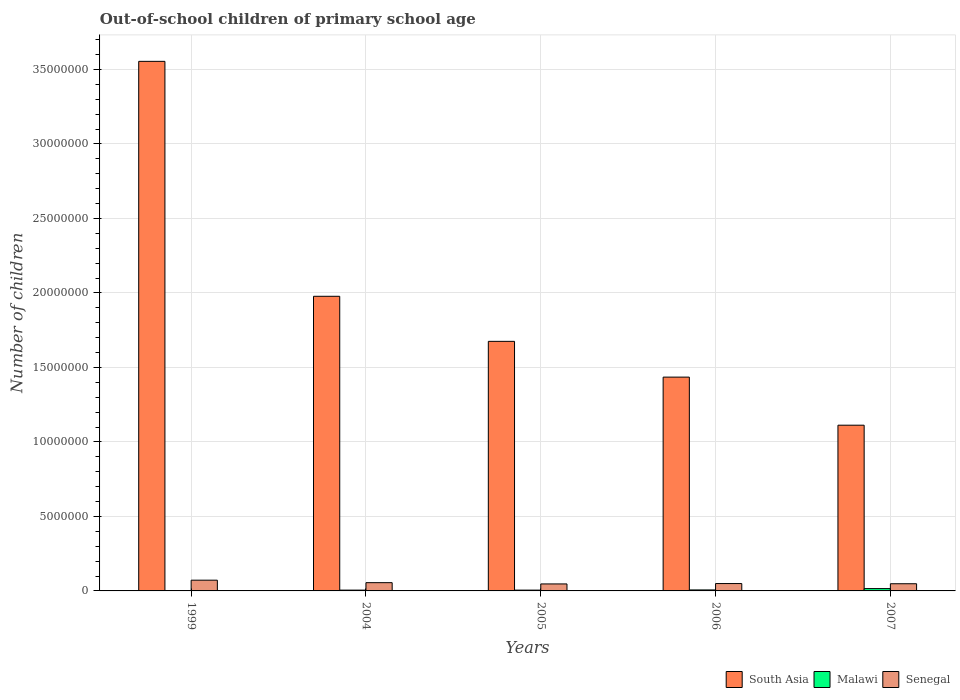How many different coloured bars are there?
Your answer should be compact. 3. Are the number of bars per tick equal to the number of legend labels?
Your answer should be very brief. Yes. How many bars are there on the 1st tick from the right?
Your answer should be compact. 3. What is the number of out-of-school children in South Asia in 2004?
Offer a terse response. 1.98e+07. Across all years, what is the maximum number of out-of-school children in South Asia?
Your response must be concise. 3.55e+07. Across all years, what is the minimum number of out-of-school children in Malawi?
Give a very brief answer. 1.75e+04. In which year was the number of out-of-school children in Malawi maximum?
Provide a short and direct response. 2007. What is the total number of out-of-school children in Malawi in the graph?
Your response must be concise. 3.49e+05. What is the difference between the number of out-of-school children in Senegal in 2005 and that in 2007?
Your response must be concise. -1.23e+04. What is the difference between the number of out-of-school children in South Asia in 2007 and the number of out-of-school children in Senegal in 2006?
Your answer should be compact. 1.06e+07. What is the average number of out-of-school children in Senegal per year?
Your answer should be compact. 5.44e+05. In the year 2006, what is the difference between the number of out-of-school children in South Asia and number of out-of-school children in Malawi?
Your response must be concise. 1.43e+07. In how many years, is the number of out-of-school children in South Asia greater than 27000000?
Make the answer very short. 1. What is the ratio of the number of out-of-school children in Senegal in 1999 to that in 2006?
Make the answer very short. 1.46. Is the number of out-of-school children in Senegal in 1999 less than that in 2005?
Offer a very short reply. No. Is the difference between the number of out-of-school children in South Asia in 1999 and 2007 greater than the difference between the number of out-of-school children in Malawi in 1999 and 2007?
Give a very brief answer. Yes. What is the difference between the highest and the second highest number of out-of-school children in Malawi?
Give a very brief answer. 9.06e+04. What is the difference between the highest and the lowest number of out-of-school children in Senegal?
Make the answer very short. 2.52e+05. In how many years, is the number of out-of-school children in South Asia greater than the average number of out-of-school children in South Asia taken over all years?
Your response must be concise. 2. How many bars are there?
Provide a succinct answer. 15. Are all the bars in the graph horizontal?
Provide a short and direct response. No. How many years are there in the graph?
Give a very brief answer. 5. Does the graph contain any zero values?
Your answer should be very brief. No. Does the graph contain grids?
Offer a very short reply. Yes. Where does the legend appear in the graph?
Your response must be concise. Bottom right. How are the legend labels stacked?
Your answer should be compact. Horizontal. What is the title of the graph?
Ensure brevity in your answer.  Out-of-school children of primary school age. What is the label or title of the Y-axis?
Your answer should be very brief. Number of children. What is the Number of children in South Asia in 1999?
Your answer should be compact. 3.55e+07. What is the Number of children of Malawi in 1999?
Ensure brevity in your answer.  1.75e+04. What is the Number of children of Senegal in 1999?
Keep it short and to the point. 7.21e+05. What is the Number of children in South Asia in 2004?
Give a very brief answer. 1.98e+07. What is the Number of children of Malawi in 2004?
Offer a very short reply. 5.41e+04. What is the Number of children in Senegal in 2004?
Your response must be concise. 5.54e+05. What is the Number of children in South Asia in 2005?
Keep it short and to the point. 1.67e+07. What is the Number of children in Malawi in 2005?
Provide a short and direct response. 5.37e+04. What is the Number of children in Senegal in 2005?
Your answer should be very brief. 4.69e+05. What is the Number of children of South Asia in 2006?
Provide a succinct answer. 1.44e+07. What is the Number of children in Malawi in 2006?
Your answer should be compact. 6.66e+04. What is the Number of children in Senegal in 2006?
Your answer should be very brief. 4.95e+05. What is the Number of children of South Asia in 2007?
Provide a succinct answer. 1.11e+07. What is the Number of children of Malawi in 2007?
Provide a short and direct response. 1.57e+05. What is the Number of children of Senegal in 2007?
Provide a short and direct response. 4.81e+05. Across all years, what is the maximum Number of children in South Asia?
Offer a very short reply. 3.55e+07. Across all years, what is the maximum Number of children in Malawi?
Your answer should be compact. 1.57e+05. Across all years, what is the maximum Number of children of Senegal?
Your answer should be compact. 7.21e+05. Across all years, what is the minimum Number of children of South Asia?
Provide a succinct answer. 1.11e+07. Across all years, what is the minimum Number of children of Malawi?
Provide a short and direct response. 1.75e+04. Across all years, what is the minimum Number of children in Senegal?
Your answer should be compact. 4.69e+05. What is the total Number of children of South Asia in the graph?
Provide a short and direct response. 9.75e+07. What is the total Number of children in Malawi in the graph?
Provide a succinct answer. 3.49e+05. What is the total Number of children of Senegal in the graph?
Provide a short and direct response. 2.72e+06. What is the difference between the Number of children in South Asia in 1999 and that in 2004?
Your response must be concise. 1.58e+07. What is the difference between the Number of children of Malawi in 1999 and that in 2004?
Ensure brevity in your answer.  -3.66e+04. What is the difference between the Number of children of Senegal in 1999 and that in 2004?
Make the answer very short. 1.66e+05. What is the difference between the Number of children of South Asia in 1999 and that in 2005?
Ensure brevity in your answer.  1.88e+07. What is the difference between the Number of children in Malawi in 1999 and that in 2005?
Your answer should be very brief. -3.62e+04. What is the difference between the Number of children in Senegal in 1999 and that in 2005?
Give a very brief answer. 2.52e+05. What is the difference between the Number of children in South Asia in 1999 and that in 2006?
Your answer should be compact. 2.12e+07. What is the difference between the Number of children in Malawi in 1999 and that in 2006?
Your answer should be compact. -4.91e+04. What is the difference between the Number of children of Senegal in 1999 and that in 2006?
Your answer should be compact. 2.26e+05. What is the difference between the Number of children in South Asia in 1999 and that in 2007?
Provide a succinct answer. 2.44e+07. What is the difference between the Number of children of Malawi in 1999 and that in 2007?
Ensure brevity in your answer.  -1.40e+05. What is the difference between the Number of children of Senegal in 1999 and that in 2007?
Provide a short and direct response. 2.39e+05. What is the difference between the Number of children of South Asia in 2004 and that in 2005?
Give a very brief answer. 3.03e+06. What is the difference between the Number of children in Malawi in 2004 and that in 2005?
Your answer should be very brief. 376. What is the difference between the Number of children in Senegal in 2004 and that in 2005?
Your response must be concise. 8.52e+04. What is the difference between the Number of children in South Asia in 2004 and that in 2006?
Your answer should be very brief. 5.42e+06. What is the difference between the Number of children of Malawi in 2004 and that in 2006?
Give a very brief answer. -1.25e+04. What is the difference between the Number of children of Senegal in 2004 and that in 2006?
Keep it short and to the point. 5.97e+04. What is the difference between the Number of children in South Asia in 2004 and that in 2007?
Make the answer very short. 8.65e+06. What is the difference between the Number of children of Malawi in 2004 and that in 2007?
Ensure brevity in your answer.  -1.03e+05. What is the difference between the Number of children of Senegal in 2004 and that in 2007?
Give a very brief answer. 7.29e+04. What is the difference between the Number of children of South Asia in 2005 and that in 2006?
Ensure brevity in your answer.  2.40e+06. What is the difference between the Number of children in Malawi in 2005 and that in 2006?
Give a very brief answer. -1.29e+04. What is the difference between the Number of children of Senegal in 2005 and that in 2006?
Provide a short and direct response. -2.55e+04. What is the difference between the Number of children of South Asia in 2005 and that in 2007?
Ensure brevity in your answer.  5.63e+06. What is the difference between the Number of children of Malawi in 2005 and that in 2007?
Your response must be concise. -1.03e+05. What is the difference between the Number of children in Senegal in 2005 and that in 2007?
Your answer should be compact. -1.23e+04. What is the difference between the Number of children of South Asia in 2006 and that in 2007?
Make the answer very short. 3.23e+06. What is the difference between the Number of children of Malawi in 2006 and that in 2007?
Your answer should be very brief. -9.06e+04. What is the difference between the Number of children in Senegal in 2006 and that in 2007?
Keep it short and to the point. 1.32e+04. What is the difference between the Number of children in South Asia in 1999 and the Number of children in Malawi in 2004?
Provide a short and direct response. 3.55e+07. What is the difference between the Number of children in South Asia in 1999 and the Number of children in Senegal in 2004?
Make the answer very short. 3.50e+07. What is the difference between the Number of children in Malawi in 1999 and the Number of children in Senegal in 2004?
Your response must be concise. -5.37e+05. What is the difference between the Number of children in South Asia in 1999 and the Number of children in Malawi in 2005?
Your answer should be compact. 3.55e+07. What is the difference between the Number of children of South Asia in 1999 and the Number of children of Senegal in 2005?
Keep it short and to the point. 3.51e+07. What is the difference between the Number of children in Malawi in 1999 and the Number of children in Senegal in 2005?
Your answer should be very brief. -4.52e+05. What is the difference between the Number of children in South Asia in 1999 and the Number of children in Malawi in 2006?
Keep it short and to the point. 3.55e+07. What is the difference between the Number of children in South Asia in 1999 and the Number of children in Senegal in 2006?
Offer a terse response. 3.50e+07. What is the difference between the Number of children of Malawi in 1999 and the Number of children of Senegal in 2006?
Your answer should be compact. -4.77e+05. What is the difference between the Number of children in South Asia in 1999 and the Number of children in Malawi in 2007?
Offer a very short reply. 3.54e+07. What is the difference between the Number of children in South Asia in 1999 and the Number of children in Senegal in 2007?
Ensure brevity in your answer.  3.51e+07. What is the difference between the Number of children of Malawi in 1999 and the Number of children of Senegal in 2007?
Offer a very short reply. -4.64e+05. What is the difference between the Number of children in South Asia in 2004 and the Number of children in Malawi in 2005?
Make the answer very short. 1.97e+07. What is the difference between the Number of children of South Asia in 2004 and the Number of children of Senegal in 2005?
Ensure brevity in your answer.  1.93e+07. What is the difference between the Number of children in Malawi in 2004 and the Number of children in Senegal in 2005?
Make the answer very short. -4.15e+05. What is the difference between the Number of children of South Asia in 2004 and the Number of children of Malawi in 2006?
Your answer should be compact. 1.97e+07. What is the difference between the Number of children in South Asia in 2004 and the Number of children in Senegal in 2006?
Provide a succinct answer. 1.93e+07. What is the difference between the Number of children of Malawi in 2004 and the Number of children of Senegal in 2006?
Your answer should be very brief. -4.41e+05. What is the difference between the Number of children in South Asia in 2004 and the Number of children in Malawi in 2007?
Offer a very short reply. 1.96e+07. What is the difference between the Number of children of South Asia in 2004 and the Number of children of Senegal in 2007?
Provide a short and direct response. 1.93e+07. What is the difference between the Number of children of Malawi in 2004 and the Number of children of Senegal in 2007?
Make the answer very short. -4.27e+05. What is the difference between the Number of children in South Asia in 2005 and the Number of children in Malawi in 2006?
Ensure brevity in your answer.  1.67e+07. What is the difference between the Number of children of South Asia in 2005 and the Number of children of Senegal in 2006?
Provide a succinct answer. 1.63e+07. What is the difference between the Number of children in Malawi in 2005 and the Number of children in Senegal in 2006?
Provide a succinct answer. -4.41e+05. What is the difference between the Number of children in South Asia in 2005 and the Number of children in Malawi in 2007?
Your response must be concise. 1.66e+07. What is the difference between the Number of children of South Asia in 2005 and the Number of children of Senegal in 2007?
Offer a terse response. 1.63e+07. What is the difference between the Number of children in Malawi in 2005 and the Number of children in Senegal in 2007?
Your response must be concise. -4.28e+05. What is the difference between the Number of children of South Asia in 2006 and the Number of children of Malawi in 2007?
Give a very brief answer. 1.42e+07. What is the difference between the Number of children in South Asia in 2006 and the Number of children in Senegal in 2007?
Make the answer very short. 1.39e+07. What is the difference between the Number of children of Malawi in 2006 and the Number of children of Senegal in 2007?
Offer a terse response. -4.15e+05. What is the average Number of children of South Asia per year?
Provide a succinct answer. 1.95e+07. What is the average Number of children of Malawi per year?
Keep it short and to the point. 6.98e+04. What is the average Number of children in Senegal per year?
Give a very brief answer. 5.44e+05. In the year 1999, what is the difference between the Number of children of South Asia and Number of children of Malawi?
Keep it short and to the point. 3.55e+07. In the year 1999, what is the difference between the Number of children of South Asia and Number of children of Senegal?
Your answer should be very brief. 3.48e+07. In the year 1999, what is the difference between the Number of children of Malawi and Number of children of Senegal?
Provide a short and direct response. -7.03e+05. In the year 2004, what is the difference between the Number of children of South Asia and Number of children of Malawi?
Your response must be concise. 1.97e+07. In the year 2004, what is the difference between the Number of children of South Asia and Number of children of Senegal?
Provide a short and direct response. 1.92e+07. In the year 2004, what is the difference between the Number of children in Malawi and Number of children in Senegal?
Keep it short and to the point. -5.00e+05. In the year 2005, what is the difference between the Number of children in South Asia and Number of children in Malawi?
Your answer should be compact. 1.67e+07. In the year 2005, what is the difference between the Number of children in South Asia and Number of children in Senegal?
Provide a short and direct response. 1.63e+07. In the year 2005, what is the difference between the Number of children in Malawi and Number of children in Senegal?
Your answer should be compact. -4.15e+05. In the year 2006, what is the difference between the Number of children in South Asia and Number of children in Malawi?
Offer a very short reply. 1.43e+07. In the year 2006, what is the difference between the Number of children in South Asia and Number of children in Senegal?
Provide a succinct answer. 1.39e+07. In the year 2006, what is the difference between the Number of children in Malawi and Number of children in Senegal?
Your answer should be compact. -4.28e+05. In the year 2007, what is the difference between the Number of children in South Asia and Number of children in Malawi?
Offer a very short reply. 1.10e+07. In the year 2007, what is the difference between the Number of children of South Asia and Number of children of Senegal?
Ensure brevity in your answer.  1.06e+07. In the year 2007, what is the difference between the Number of children in Malawi and Number of children in Senegal?
Give a very brief answer. -3.24e+05. What is the ratio of the Number of children in South Asia in 1999 to that in 2004?
Offer a terse response. 1.8. What is the ratio of the Number of children in Malawi in 1999 to that in 2004?
Your response must be concise. 0.32. What is the ratio of the Number of children of Senegal in 1999 to that in 2004?
Offer a very short reply. 1.3. What is the ratio of the Number of children of South Asia in 1999 to that in 2005?
Keep it short and to the point. 2.12. What is the ratio of the Number of children of Malawi in 1999 to that in 2005?
Give a very brief answer. 0.33. What is the ratio of the Number of children in Senegal in 1999 to that in 2005?
Provide a short and direct response. 1.54. What is the ratio of the Number of children of South Asia in 1999 to that in 2006?
Your response must be concise. 2.48. What is the ratio of the Number of children of Malawi in 1999 to that in 2006?
Provide a succinct answer. 0.26. What is the ratio of the Number of children in Senegal in 1999 to that in 2006?
Give a very brief answer. 1.46. What is the ratio of the Number of children of South Asia in 1999 to that in 2007?
Your answer should be compact. 3.2. What is the ratio of the Number of children in Malawi in 1999 to that in 2007?
Provide a short and direct response. 0.11. What is the ratio of the Number of children in Senegal in 1999 to that in 2007?
Offer a terse response. 1.5. What is the ratio of the Number of children of South Asia in 2004 to that in 2005?
Your answer should be compact. 1.18. What is the ratio of the Number of children of Malawi in 2004 to that in 2005?
Make the answer very short. 1.01. What is the ratio of the Number of children of Senegal in 2004 to that in 2005?
Provide a short and direct response. 1.18. What is the ratio of the Number of children in South Asia in 2004 to that in 2006?
Your answer should be very brief. 1.38. What is the ratio of the Number of children of Malawi in 2004 to that in 2006?
Keep it short and to the point. 0.81. What is the ratio of the Number of children of Senegal in 2004 to that in 2006?
Ensure brevity in your answer.  1.12. What is the ratio of the Number of children in South Asia in 2004 to that in 2007?
Ensure brevity in your answer.  1.78. What is the ratio of the Number of children of Malawi in 2004 to that in 2007?
Your answer should be very brief. 0.34. What is the ratio of the Number of children in Senegal in 2004 to that in 2007?
Your response must be concise. 1.15. What is the ratio of the Number of children of South Asia in 2005 to that in 2006?
Give a very brief answer. 1.17. What is the ratio of the Number of children of Malawi in 2005 to that in 2006?
Make the answer very short. 0.81. What is the ratio of the Number of children in Senegal in 2005 to that in 2006?
Make the answer very short. 0.95. What is the ratio of the Number of children of South Asia in 2005 to that in 2007?
Provide a succinct answer. 1.51. What is the ratio of the Number of children of Malawi in 2005 to that in 2007?
Ensure brevity in your answer.  0.34. What is the ratio of the Number of children of Senegal in 2005 to that in 2007?
Offer a terse response. 0.97. What is the ratio of the Number of children in South Asia in 2006 to that in 2007?
Keep it short and to the point. 1.29. What is the ratio of the Number of children of Malawi in 2006 to that in 2007?
Ensure brevity in your answer.  0.42. What is the ratio of the Number of children of Senegal in 2006 to that in 2007?
Offer a very short reply. 1.03. What is the difference between the highest and the second highest Number of children in South Asia?
Provide a succinct answer. 1.58e+07. What is the difference between the highest and the second highest Number of children in Malawi?
Ensure brevity in your answer.  9.06e+04. What is the difference between the highest and the second highest Number of children of Senegal?
Keep it short and to the point. 1.66e+05. What is the difference between the highest and the lowest Number of children in South Asia?
Your answer should be very brief. 2.44e+07. What is the difference between the highest and the lowest Number of children in Malawi?
Your response must be concise. 1.40e+05. What is the difference between the highest and the lowest Number of children in Senegal?
Keep it short and to the point. 2.52e+05. 